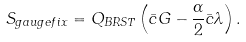Convert formula to latex. <formula><loc_0><loc_0><loc_500><loc_500>S _ { g a u g e f i x } = Q _ { B R S T } \left ( \bar { c } G - \frac { \alpha } { 2 } \bar { c } \lambda \right ) .</formula> 